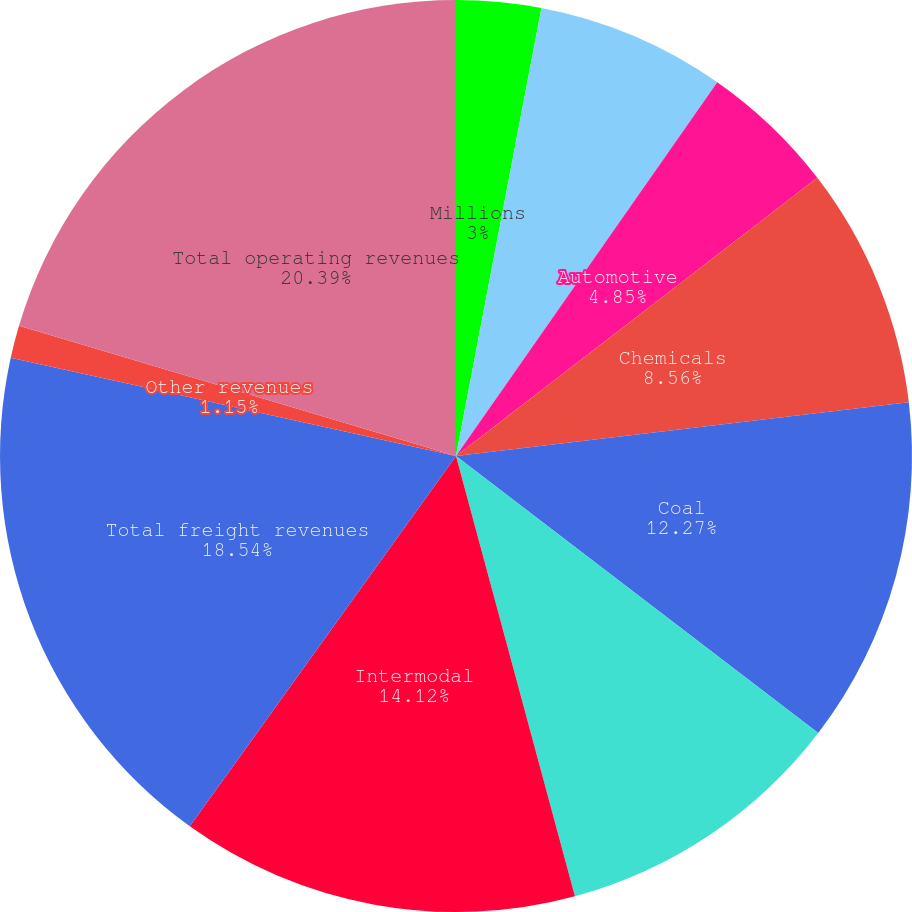Convert chart. <chart><loc_0><loc_0><loc_500><loc_500><pie_chart><fcel>Millions<fcel>Agricultural Products<fcel>Automotive<fcel>Chemicals<fcel>Coal<fcel>Industrial Products<fcel>Intermodal<fcel>Total freight revenues<fcel>Other revenues<fcel>Total operating revenues<nl><fcel>3.0%<fcel>6.71%<fcel>4.85%<fcel>8.56%<fcel>12.27%<fcel>10.41%<fcel>14.12%<fcel>18.54%<fcel>1.15%<fcel>20.39%<nl></chart> 